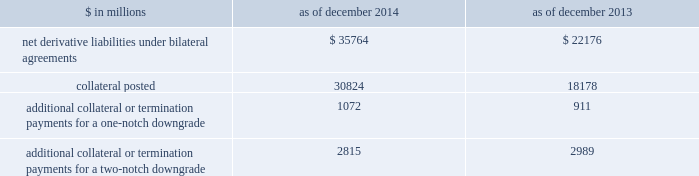Notes to consolidated financial statements derivatives with credit-related contingent features certain of the firm 2019s derivatives have been transacted under bilateral agreements with counterparties who may require the firm to post collateral or terminate the transactions based on changes in the firm 2019s credit ratings .
The firm assesses the impact of these bilateral agreements by determining the collateral or termination payments that would occur assuming a downgrade by all rating agencies .
A downgrade by any one rating agency , depending on the agency 2019s relative ratings of the firm at the time of the downgrade , may have an impact which is comparable to the impact of a downgrade by all rating agencies .
The table below presents the aggregate fair value of net derivative liabilities under such agreements ( excluding application of collateral posted to reduce these liabilities ) , the related aggregate fair value of the assets posted as collateral , and the additional collateral or termination payments that could have been called at the reporting date by counterparties in the event of a one-notch and two-notch downgrade in the firm 2019s credit ratings. .
Additional collateral or termination payments for a one-notch downgrade 1072 911 additional collateral or termination payments for a two-notch downgrade 2815 2989 credit derivatives the firm enters into a broad array of credit derivatives in locations around the world to facilitate client transactions and to manage the credit risk associated with market- making and investing and lending activities .
Credit derivatives are actively managed based on the firm 2019s net risk position .
Credit derivatives are individually negotiated contracts and can have various settlement and payment conventions .
Credit events include failure to pay , bankruptcy , acceleration of indebtedness , restructuring , repudiation and dissolution of the reference entity .
Credit default swaps .
Single-name credit default swaps protect the buyer against the loss of principal on one or more bonds , loans or mortgages ( reference obligations ) in the event the issuer ( reference entity ) of the reference obligations suffers a credit event .
The buyer of protection pays an initial or periodic premium to the seller and receives protection for the period of the contract .
If there is no credit event , as defined in the contract , the seller of protection makes no payments to the buyer of protection .
However , if a credit event occurs , the seller of protection is required to make a payment to the buyer of protection , which is calculated in accordance with the terms of the contract .
Credit indices , baskets and tranches .
Credit derivatives may reference a basket of single-name credit default swaps or a broad-based index .
If a credit event occurs in one of the underlying reference obligations , the protection seller pays the protection buyer .
The payment is typically a pro-rata portion of the transaction 2019s total notional amount based on the underlying defaulted reference obligation .
In certain transactions , the credit risk of a basket or index is separated into various portions ( tranches ) , each having different levels of subordination .
The most junior tranches cover initial defaults and once losses exceed the notional amount of these junior tranches , any excess loss is covered by the next most senior tranche in the capital structure .
Total return swaps .
A total return swap transfers the risks relating to economic performance of a reference obligation from the protection buyer to the protection seller .
Typically , the protection buyer receives from the protection seller a floating rate of interest and protection against any reduction in fair value of the reference obligation , and in return the protection seller receives the cash flows associated with the reference obligation , plus any increase in the fair value of the reference obligation .
132 goldman sachs 2014 annual report .
In millions between 2014 and 2013 , what was the change in net derivative liabilities under bilateral agreements?\\n? 
Computations: (35764 - 22176)
Answer: 13588.0. 